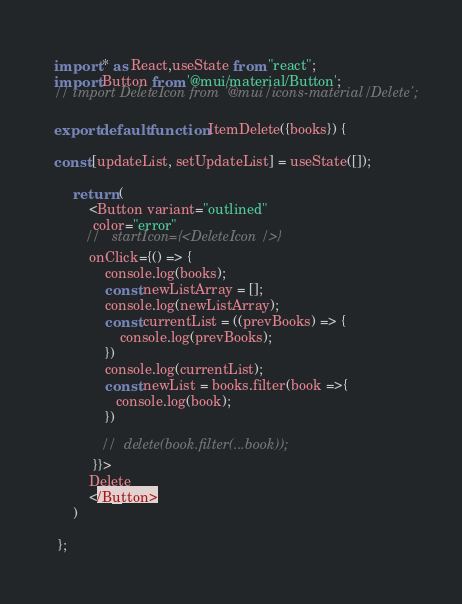Convert code to text. <code><loc_0><loc_0><loc_500><loc_500><_JavaScript_>import * as React,useState from "react";
import Button from '@mui/material/Button';
// import DeleteIcon from '@mui/icons-material/Delete';

export default function ItemDelete({books}) {

const [updateList, setUpdateList] = useState([]);

     return (
         <Button variant="outlined"
          color="error" 
        //   startIcon={<DeleteIcon />}
         onClick={() => {
             console.log(books);
             const newListArray = [];
             console.log(newListArray);
             const currentList = ((prevBooks) => {
                 console.log(prevBooks);
             })
             console.log(currentList);
             const newList = books.filter(book =>{
                console.log(book);
             })
            
            //  delete(book.filter(...book));
          }}>
         Delete 
         </Button>
     )

 };</code> 